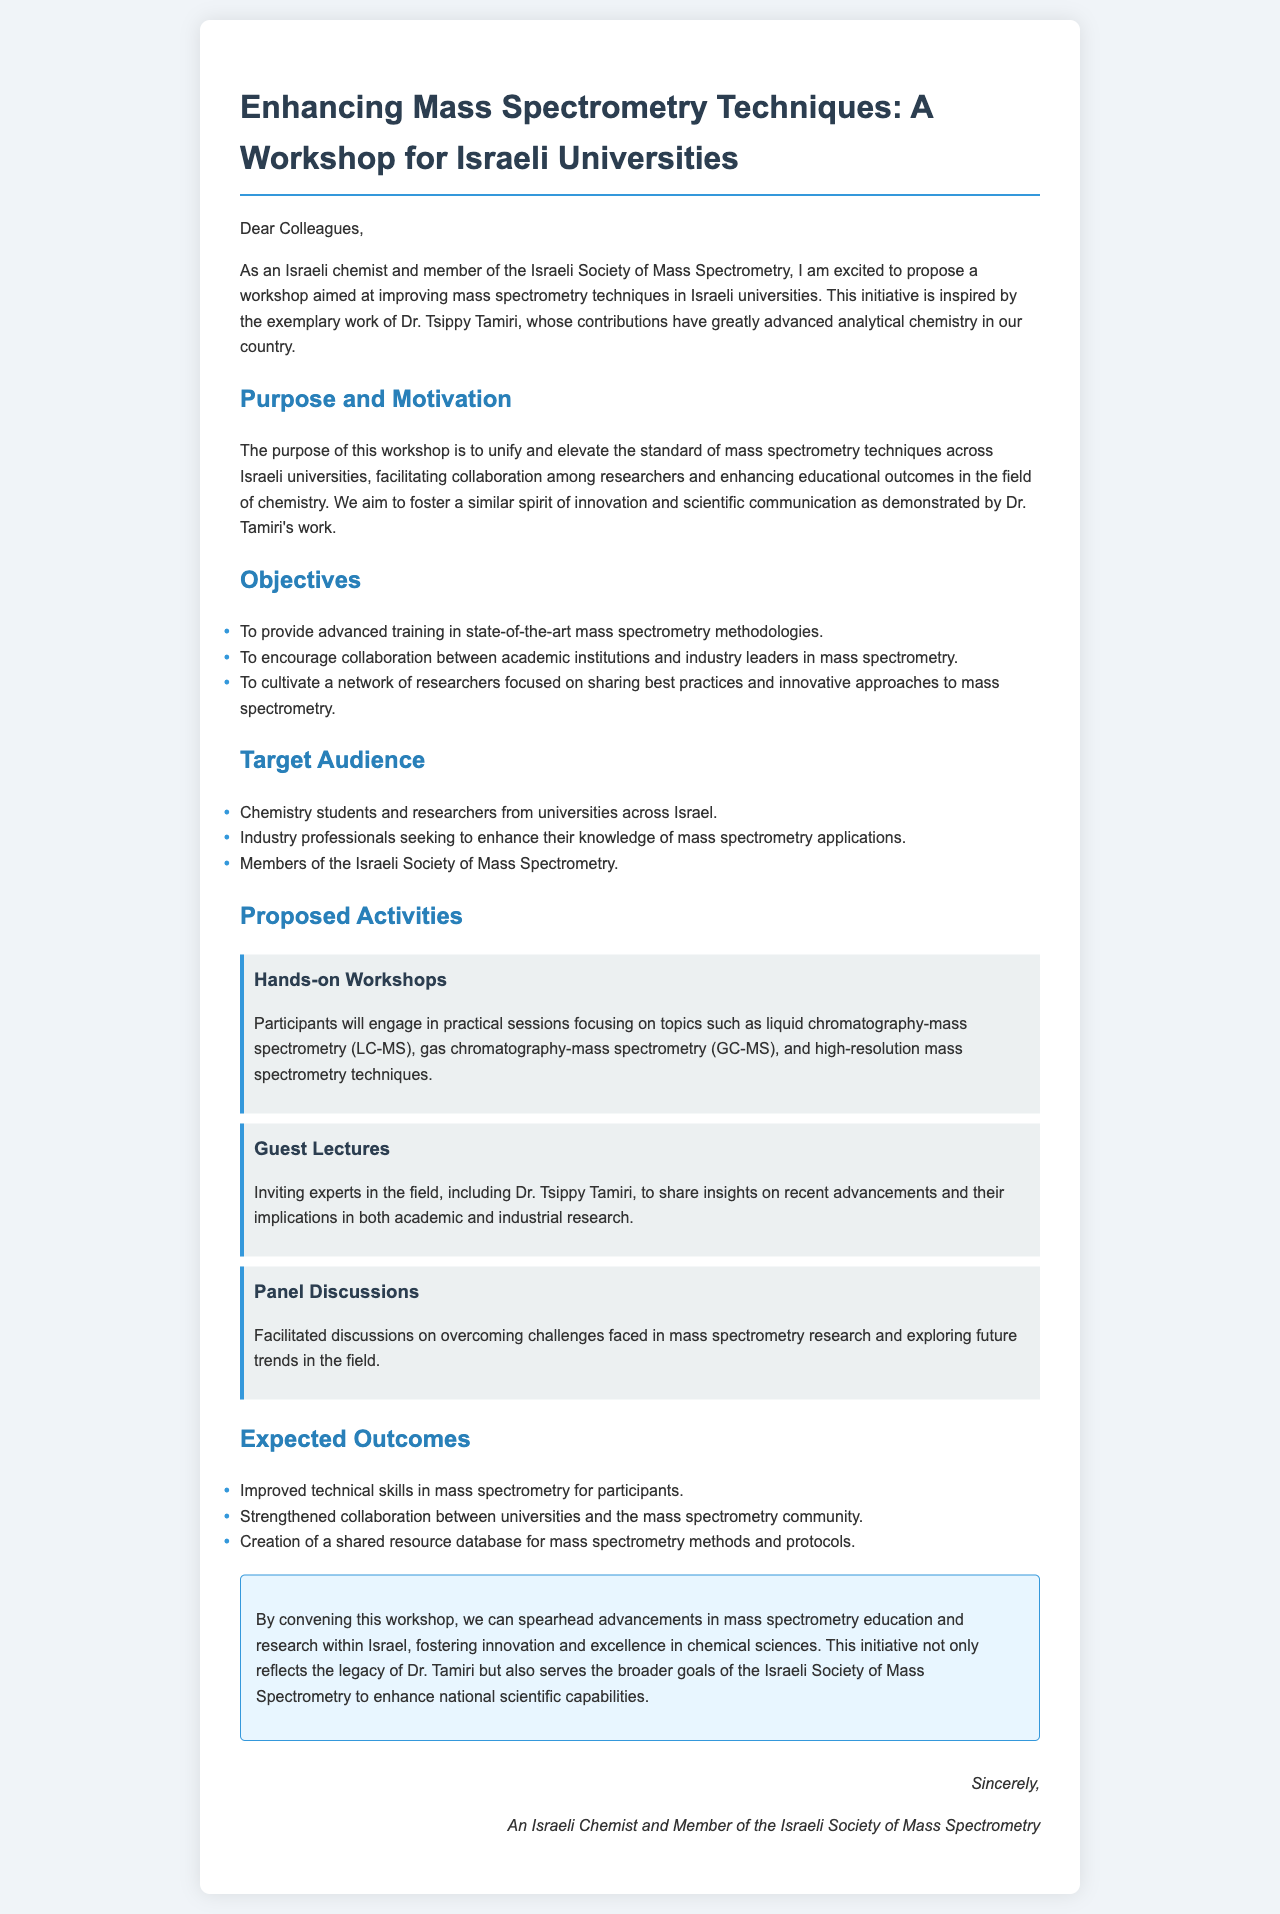what is the title of the proposal? The title of the proposal is mentioned at the top of the document, summarizing the initiative.
Answer: Enhancing Mass Spectrometry Techniques: A Workshop for Israeli Universities who is the proposed workshop inspired by? The document states the workshop is inspired by an individual's work in analytical chemistry.
Answer: Dr. Tsippy Tamiri what is one of the objectives of the workshop? The objectives are listed in a bullet point format within the document.
Answer: To provide advanced training in state-of-the-art mass spectrometry methodologies who is the target audience for the workshop? The target audience consists of specific groups outlined in the document.
Answer: Chemistry students and researchers what type of activity will include guest lectures? The proposed activities are described in sections throughout the document, specifying the nature of each activity.
Answer: Guest Lectures what is an expected outcome of the workshop? The expected outcomes are listed and provide the benefits anticipated from the workshop.
Answer: Improved technical skills in mass spectrometry for participants what is the purpose of the workshop? The purpose is explicitly stated in a section of the document, outlining the workshop's goals.
Answer: To unify and elevate the standard of mass spectrometry techniques across Israeli universities how will panel discussions contribute to the workshop? The role of panel discussions is mentioned in the context of addressing challenges and exploring future trends.
Answer: Overcoming challenges faced in mass spectrometry research 